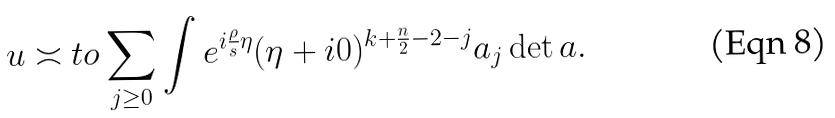<formula> <loc_0><loc_0><loc_500><loc_500>u \asymp t o \sum _ { j \geq 0 } \int e ^ { i \frac { \rho } { s } \eta } ( \eta + i 0 ) ^ { k + \frac { n } { 2 } - 2 - j } a _ { j } \det a .</formula> 